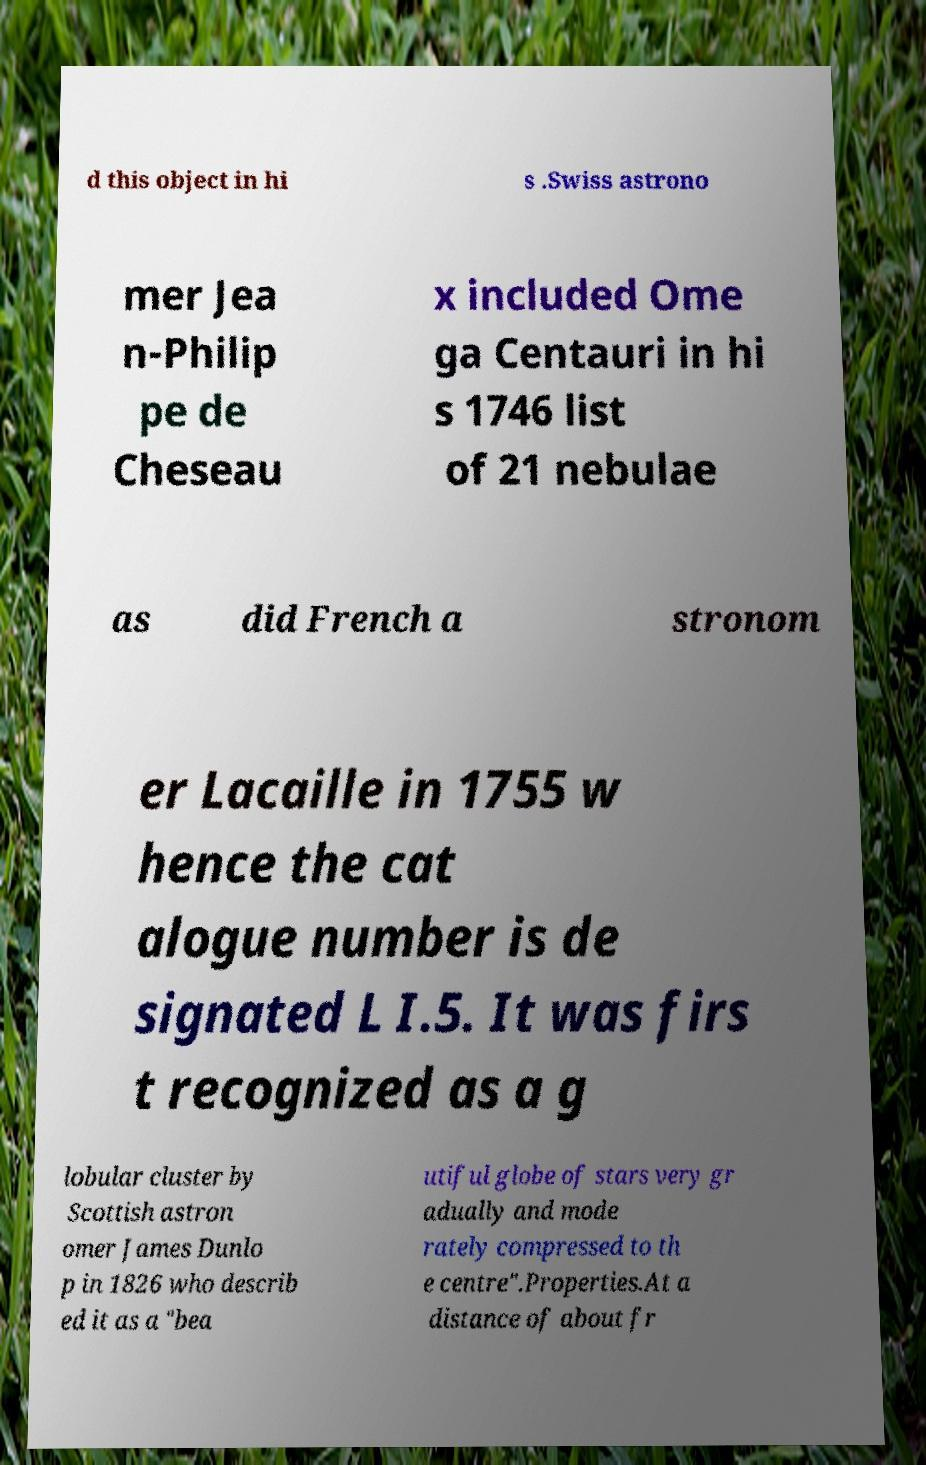Please identify and transcribe the text found in this image. d this object in hi s .Swiss astrono mer Jea n-Philip pe de Cheseau x included Ome ga Centauri in hi s 1746 list of 21 nebulae as did French a stronom er Lacaille in 1755 w hence the cat alogue number is de signated L I.5. It was firs t recognized as a g lobular cluster by Scottish astron omer James Dunlo p in 1826 who describ ed it as a "bea utiful globe of stars very gr adually and mode rately compressed to th e centre".Properties.At a distance of about fr 